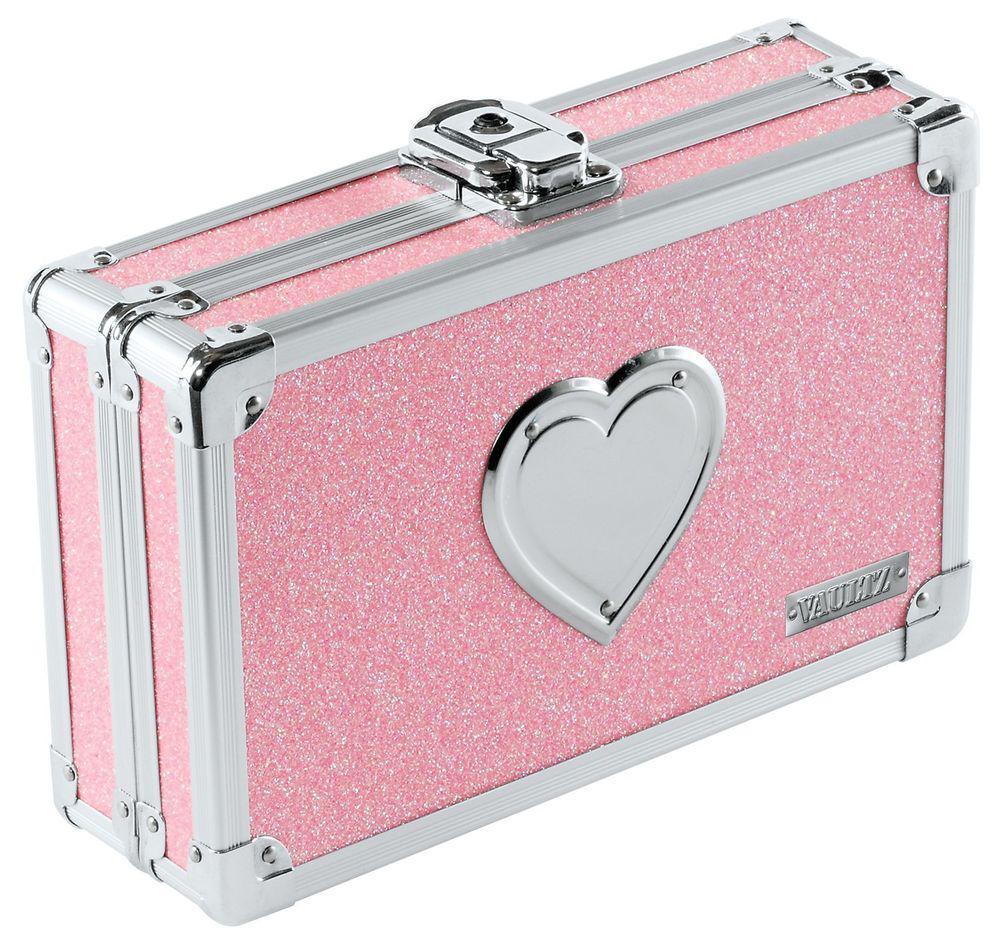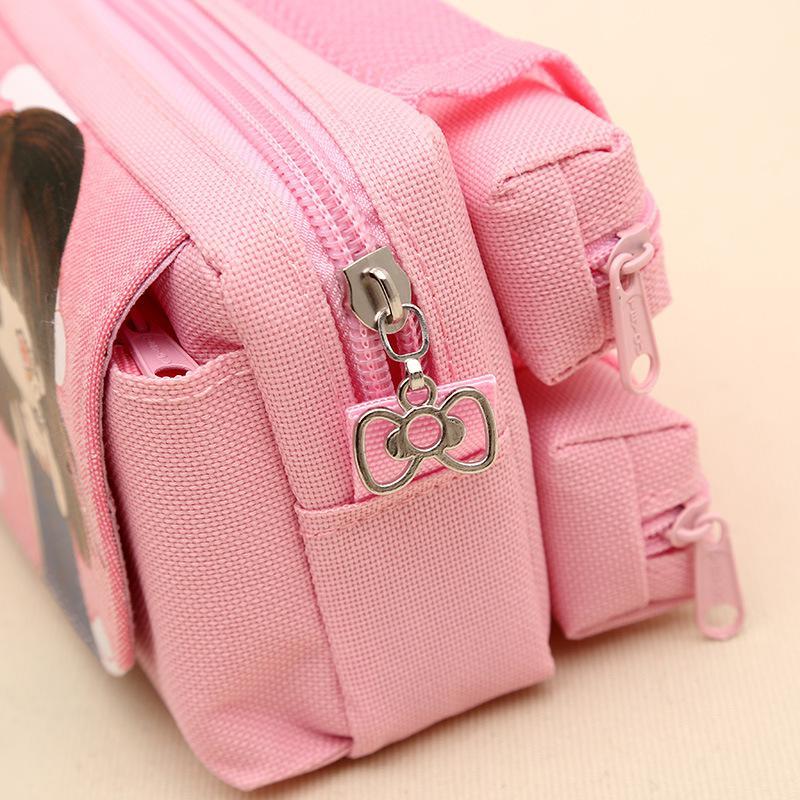The first image is the image on the left, the second image is the image on the right. Assess this claim about the two images: "The left image shows only a single pink case.". Correct or not? Answer yes or no. Yes. 